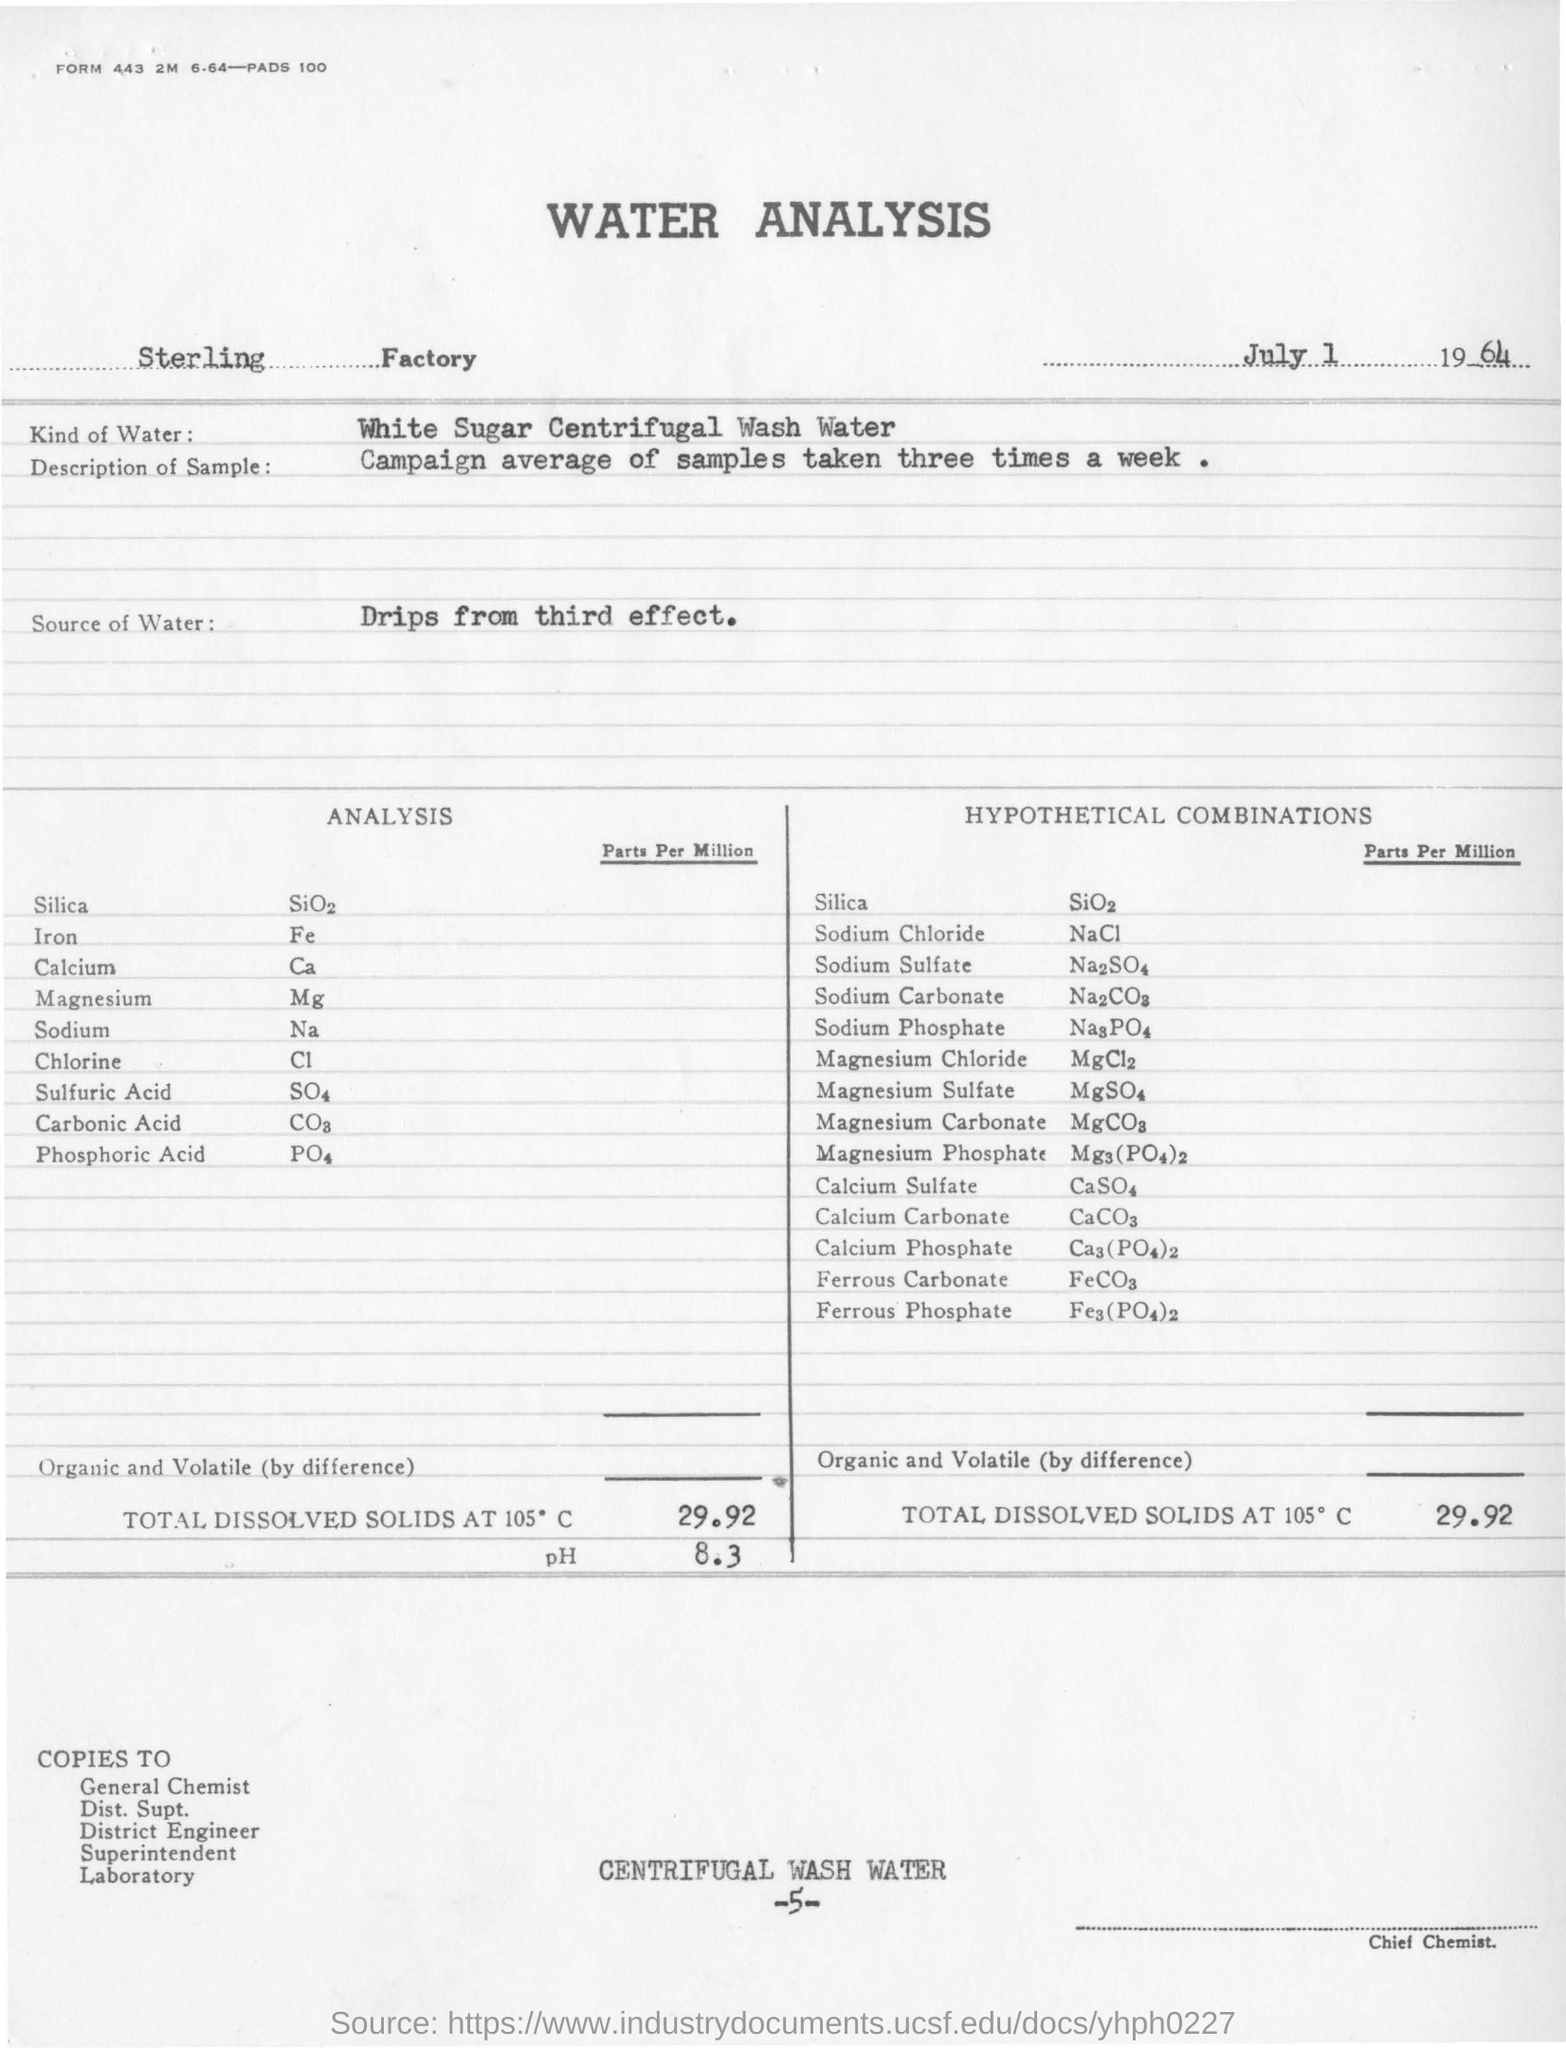What is this document about?
Offer a terse response. WATER ANALYSIS. What is the date mentioned in this document?
Provide a succinct answer. July 1 1964. Which Factory's water analysis is conducted?
Make the answer very short. Sterling     Factory. What kind of water is taken for analysis?
Provide a short and direct response. White Sugar Centrifugal Wash Water. What is the description of sample taken?
Your answer should be compact. Campaign average of samples taken three times a week. What is the Source of water for analysis?
Ensure brevity in your answer.  Drips from third effect. What is the pH maintained for Water Analysis?
Offer a terse response. 8.3. 